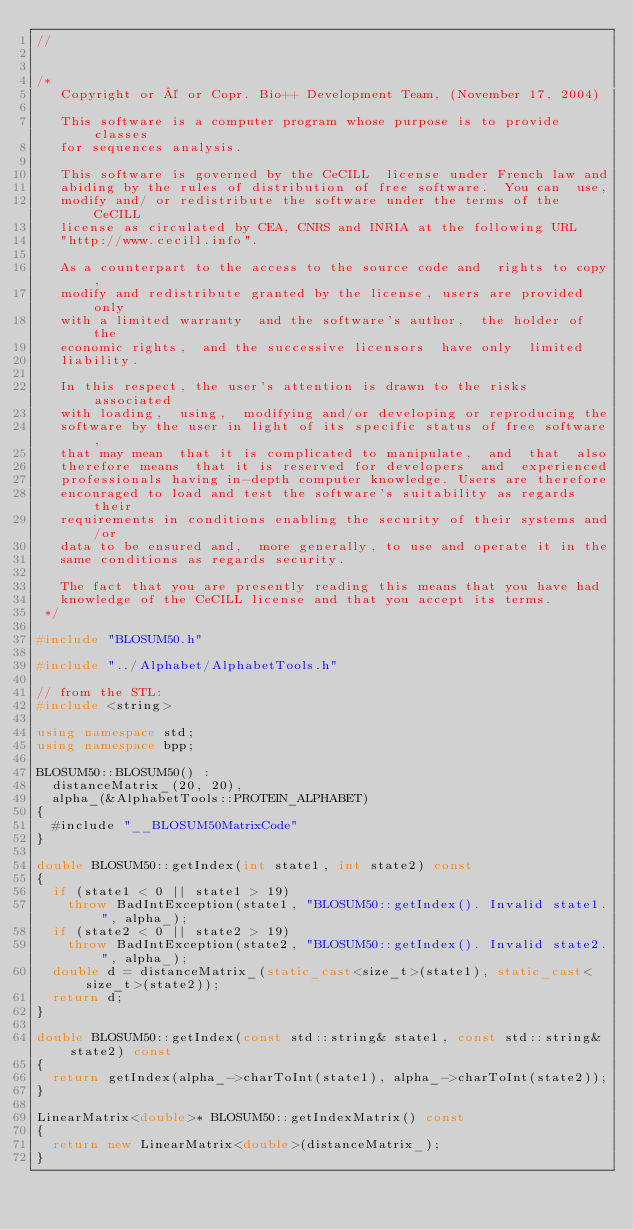<code> <loc_0><loc_0><loc_500><loc_500><_C++_>//


/*
   Copyright or © or Copr. Bio++ Development Team, (November 17, 2004)

   This software is a computer program whose purpose is to provide classes
   for sequences analysis.

   This software is governed by the CeCILL  license under French law and
   abiding by the rules of distribution of free software.  You can  use,
   modify and/ or redistribute the software under the terms of the CeCILL
   license as circulated by CEA, CNRS and INRIA at the following URL
   "http://www.cecill.info".

   As a counterpart to the access to the source code and  rights to copy,
   modify and redistribute granted by the license, users are provided only
   with a limited warranty  and the software's author,  the holder of the
   economic rights,  and the successive licensors  have only  limited
   liability.

   In this respect, the user's attention is drawn to the risks associated
   with loading,  using,  modifying and/or developing or reproducing the
   software by the user in light of its specific status of free software,
   that may mean  that it is complicated to manipulate,  and  that  also
   therefore means  that it is reserved for developers  and  experienced
   professionals having in-depth computer knowledge. Users are therefore
   encouraged to load and test the software's suitability as regards their
   requirements in conditions enabling the security of their systems and/or
   data to be ensured and,  more generally, to use and operate it in the
   same conditions as regards security.

   The fact that you are presently reading this means that you have had
   knowledge of the CeCILL license and that you accept its terms.
 */

#include "BLOSUM50.h"

#include "../Alphabet/AlphabetTools.h"

// from the STL:
#include <string>

using namespace std;
using namespace bpp;

BLOSUM50::BLOSUM50() :
  distanceMatrix_(20, 20),
  alpha_(&AlphabetTools::PROTEIN_ALPHABET)
{
  #include "__BLOSUM50MatrixCode"
}

double BLOSUM50::getIndex(int state1, int state2) const
{
  if (state1 < 0 || state1 > 19)
    throw BadIntException(state1, "BLOSUM50::getIndex(). Invalid state1.", alpha_);
  if (state2 < 0 || state2 > 19)
    throw BadIntException(state2, "BLOSUM50::getIndex(). Invalid state2.", alpha_);
  double d = distanceMatrix_(static_cast<size_t>(state1), static_cast<size_t>(state2));
  return d;
}

double BLOSUM50::getIndex(const std::string& state1, const std::string& state2) const
{
  return getIndex(alpha_->charToInt(state1), alpha_->charToInt(state2));
}

LinearMatrix<double>* BLOSUM50::getIndexMatrix() const
{
  return new LinearMatrix<double>(distanceMatrix_);
}

</code> 